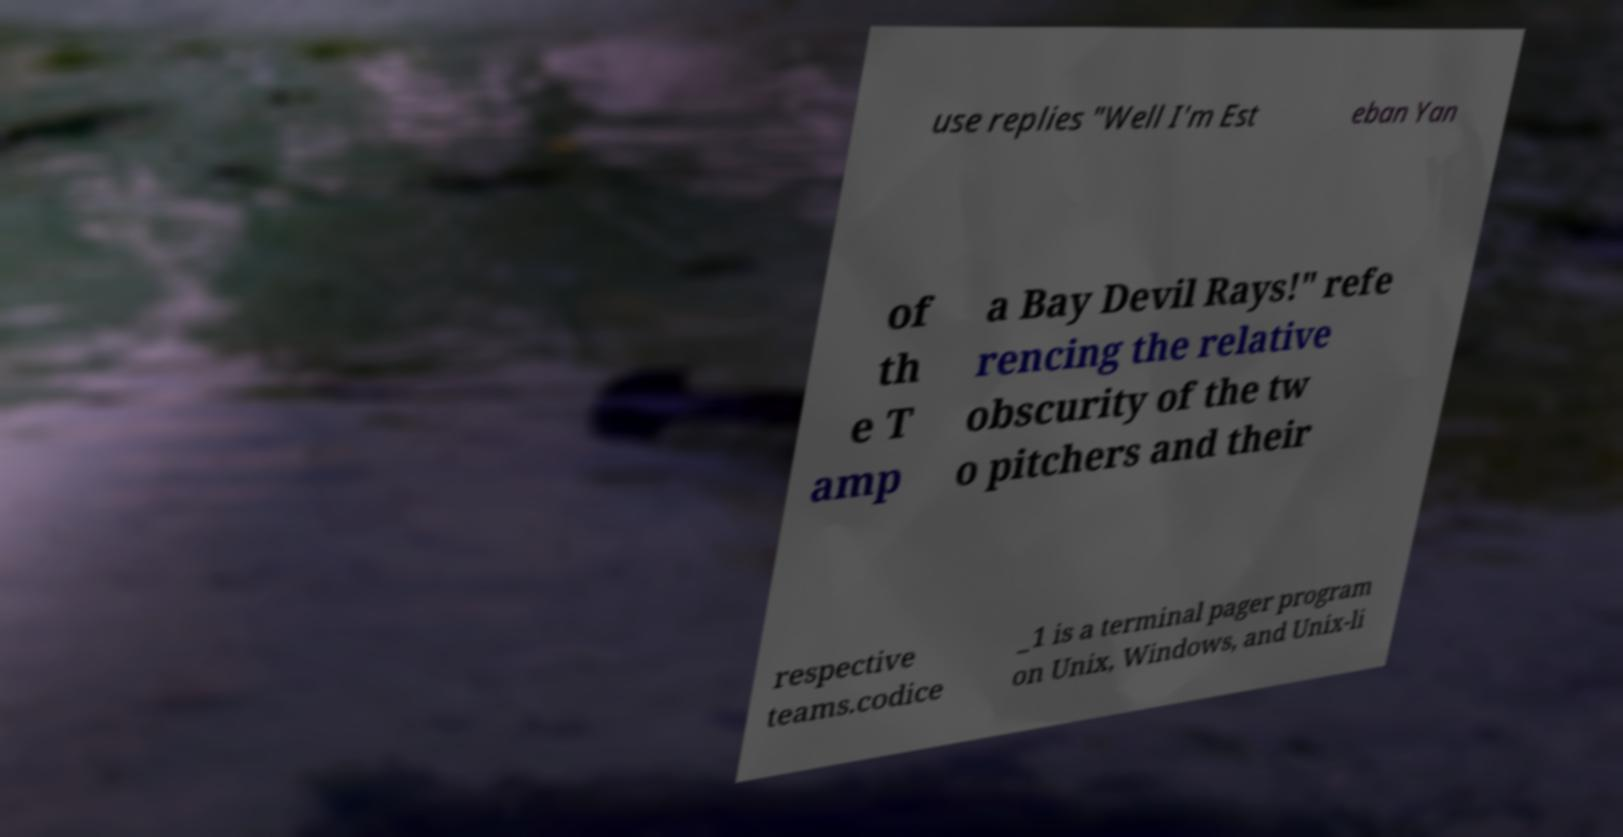Could you extract and type out the text from this image? use replies "Well I'm Est eban Yan of th e T amp a Bay Devil Rays!" refe rencing the relative obscurity of the tw o pitchers and their respective teams.codice _1 is a terminal pager program on Unix, Windows, and Unix-li 